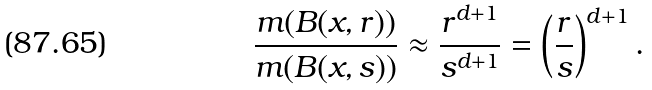Convert formula to latex. <formula><loc_0><loc_0><loc_500><loc_500>\frac { m ( B ( x , r ) ) } { m ( B ( x , s ) ) } \approx \frac { r ^ { d + 1 } } { s ^ { d + 1 } } = \left ( \frac { r } { s } \right ) ^ { d + 1 } .</formula> 